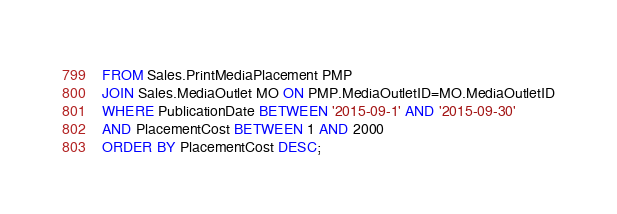<code> <loc_0><loc_0><loc_500><loc_500><_SQL_>FROM Sales.PrintMediaPlacement PMP
JOIN Sales.MediaOutlet MO ON PMP.MediaOutletID=MO.MediaOutletID
WHERE PublicationDate BETWEEN '2015-09-1' AND '2015-09-30'
AND PlacementCost BETWEEN 1 AND 2000
ORDER BY PlacementCost DESC;</code> 